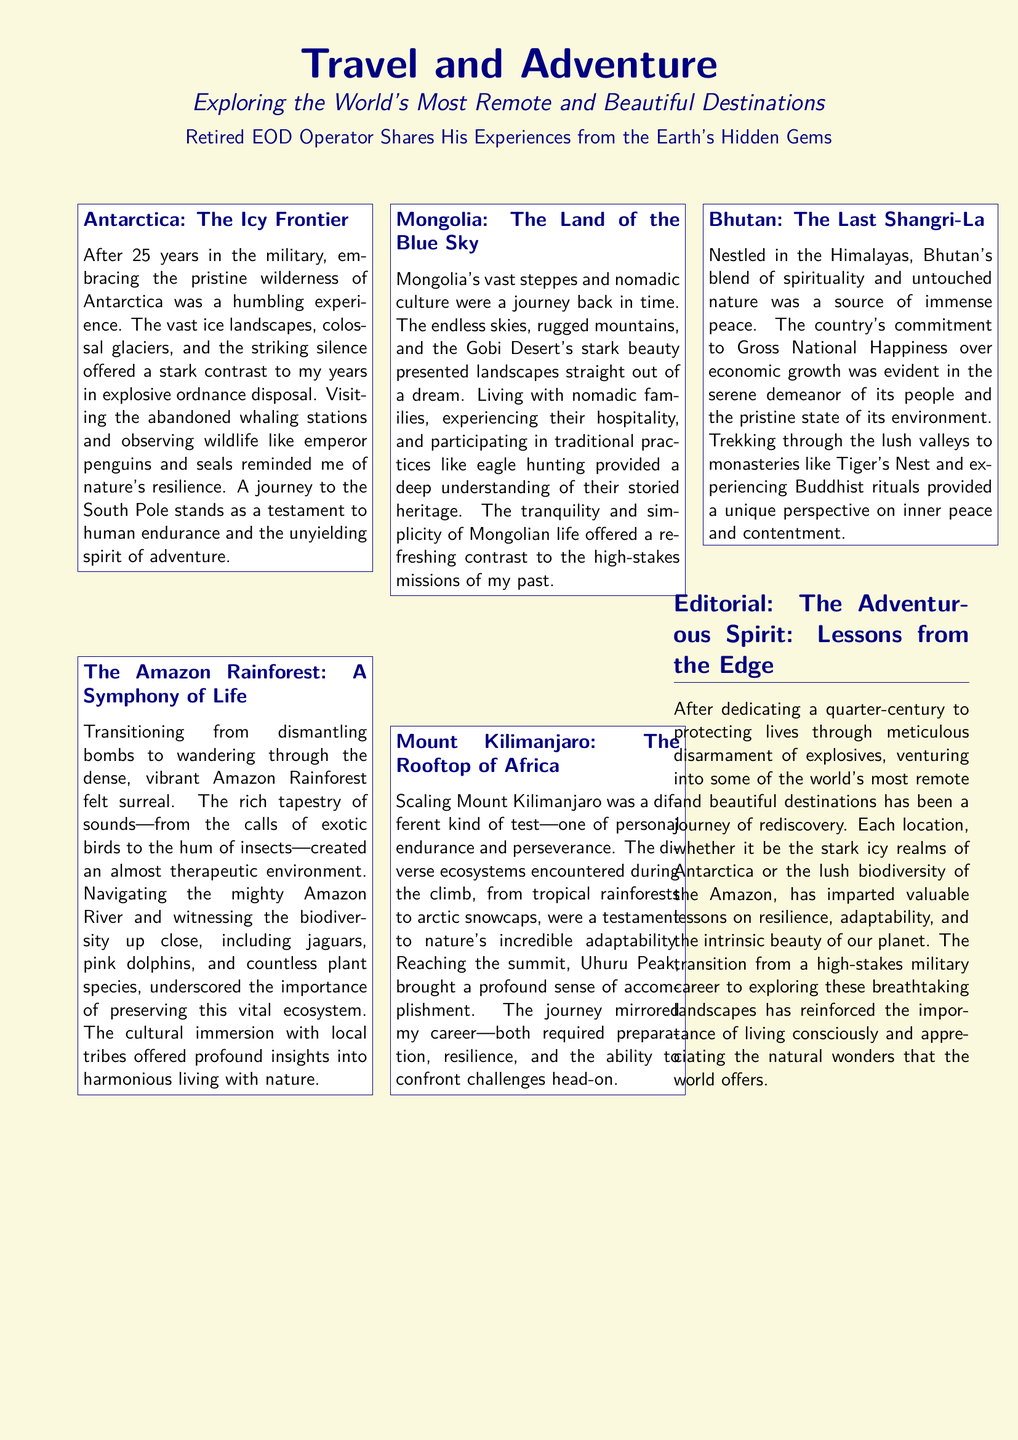What is the title of the article? The title of the article is highlighted at the top of the document in a large font.
Answer: Travel and Adventure What location is referred to as "The Icy Frontier"? This location is mentioned in the first article box of the document.
Answer: Antarctica How many destinations are explored in the document? The document lists five different destinations in total.
Answer: Five What is a unique cultural activity mentioned in Mongolia? This cultural activity is highlighted in the description of the nomadic way of life in Mongolia.
Answer: Eagle hunting Which peak is referred to as "The Rooftop of Africa"? This phrase is used to describe a specific mountain in the document.
Answer: Mount Kilimanjaro What is the significance of Bhutan's approach to happiness? This information is mentioned in the article box regarding Bhutan's values and lifestyle.
Answer: Gross National Happiness What does the author reflect on in the editorial section? The editorial contains the author's personal insights and reflections on his adventures.
Answer: Rediscovery What animal was seen in the Amazon Rainforest? This specific animal is mentioned while describing the wildlife seen in the Amazon.
Answer: Jaguars 